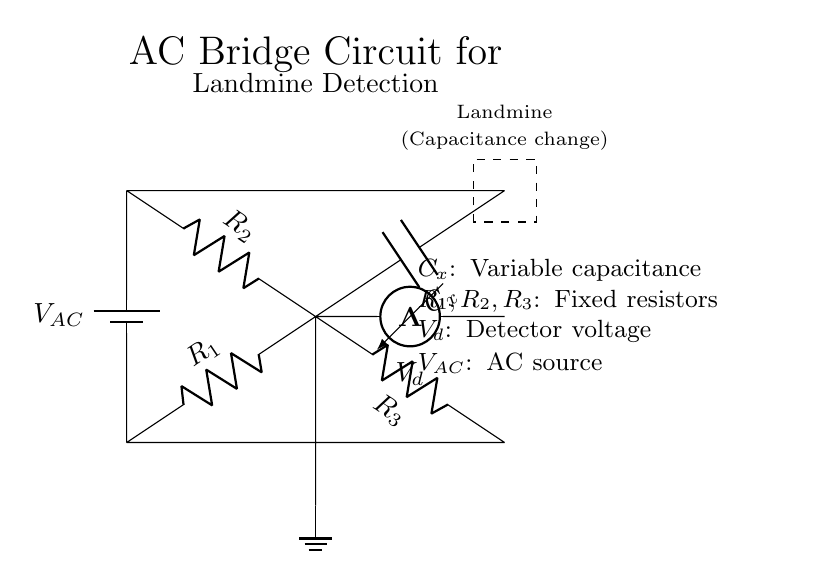What is the voltage source in this circuit? The voltage source is labeled as V_AC in the circuit diagram, indicating it is the alternating current source for the bridge circuit.
Answer: V_AC What type of component is C_x? C_x is labeled as a capacitor in the circuit diagram, which suggests it is responsible for the variable capacitance in the landmine detection setup.
Answer: Capacitor How many resistors are present in the circuit? The circuit diagram shows three resistors labeled as R_1, R_2, and R_3, indicating that three resistors are part of the bridge configuration.
Answer: Three What does the dashed rectangle represent in the circuit? The dashed rectangle in the circuit is a visual representation of a landmine, specifically highlighting its role in changing the capacitance when present.
Answer: Landmine What is the role of the voltmeter in this circuit? The voltmeter, labeled as V_d, is used to measure the voltage difference across the bridge, which helps in detecting any changes in capacitance due to the landmine.
Answer: Measure voltage What happens to the bridge balance when capacitance changes? When capacitance changes due to the presence of a landmine, it affects the voltage across the voltmeter, indicating a shift in the balance of the bridge circuit.
Answer: Affects voltage 